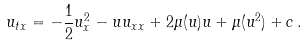Convert formula to latex. <formula><loc_0><loc_0><loc_500><loc_500>u _ { t x } = - \frac { 1 } { 2 } u _ { x } ^ { 2 } - u u _ { x x } + 2 \mu ( u ) u + \mu ( u ^ { 2 } ) + c \, .</formula> 